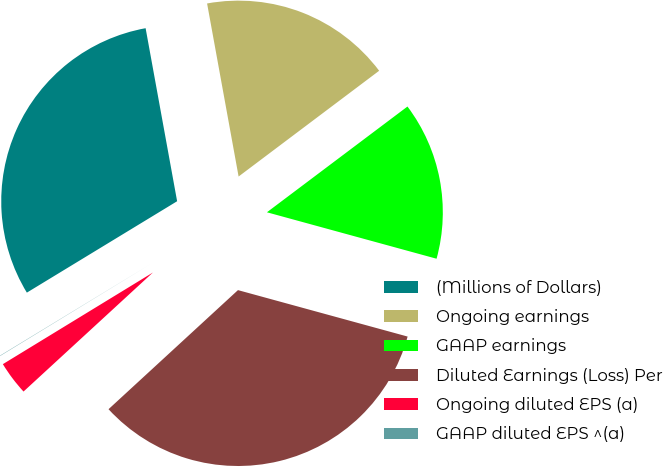Convert chart to OTSL. <chart><loc_0><loc_0><loc_500><loc_500><pie_chart><fcel>(Millions of Dollars)<fcel>Ongoing earnings<fcel>GAAP earnings<fcel>Diluted Earnings (Loss) Per<fcel>Ongoing diluted EPS (a)<fcel>GAAP diluted EPS ^(a)<nl><fcel>30.83%<fcel>17.6%<fcel>14.52%<fcel>33.91%<fcel>3.11%<fcel>0.03%<nl></chart> 